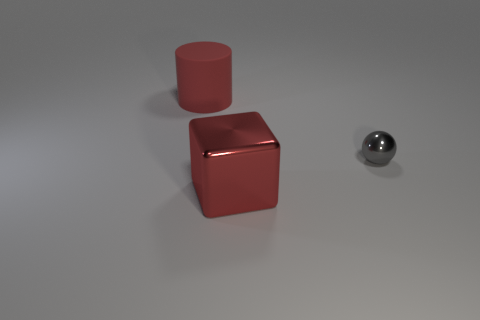Is the size of the gray ball the same as the cube?
Your answer should be compact. No. What material is the red object behind the metal ball?
Offer a terse response. Rubber. What number of other objects are there of the same shape as the big red matte object?
Keep it short and to the point. 0. Does the gray metal object have the same shape as the red rubber object?
Make the answer very short. No. Are there any shiny cubes on the left side of the small gray ball?
Your answer should be very brief. Yes. What number of objects are either small yellow rubber balls or tiny shiny things?
Give a very brief answer. 1. What number of other objects are there of the same size as the red rubber cylinder?
Offer a very short reply. 1. What number of things are right of the block and in front of the small gray thing?
Give a very brief answer. 0. Do the red thing that is in front of the tiny gray thing and the object that is left of the large shiny thing have the same size?
Provide a succinct answer. Yes. There is a red object left of the big red cube; what is its size?
Offer a very short reply. Large. 